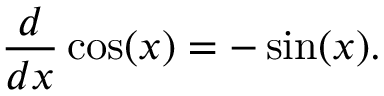Convert formula to latex. <formula><loc_0><loc_0><loc_500><loc_500>{ \frac { d } { d x } } \cos ( x ) = - \sin ( x ) .</formula> 